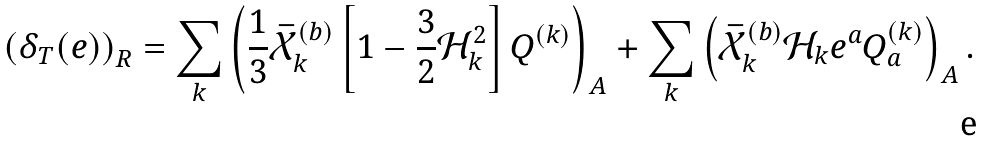<formula> <loc_0><loc_0><loc_500><loc_500>\left ( \delta _ { T } ( e ) \right ) _ { R } = \sum _ { k } \left ( { \frac { 1 } { 3 } } \bar { { \mathcal { X } } } _ { k } ^ { ( b ) } \left [ 1 - { \frac { 3 } { 2 } } { \mathcal { H } } _ { k } ^ { 2 } \right ] Q ^ { ( k ) } \right ) _ { A } + \sum _ { k } \left ( \bar { { \mathcal { X } } } _ { k } ^ { ( b ) } { \mathcal { H } } _ { k } e ^ { a } Q ^ { ( k ) } _ { a } \right ) _ { A } .</formula> 